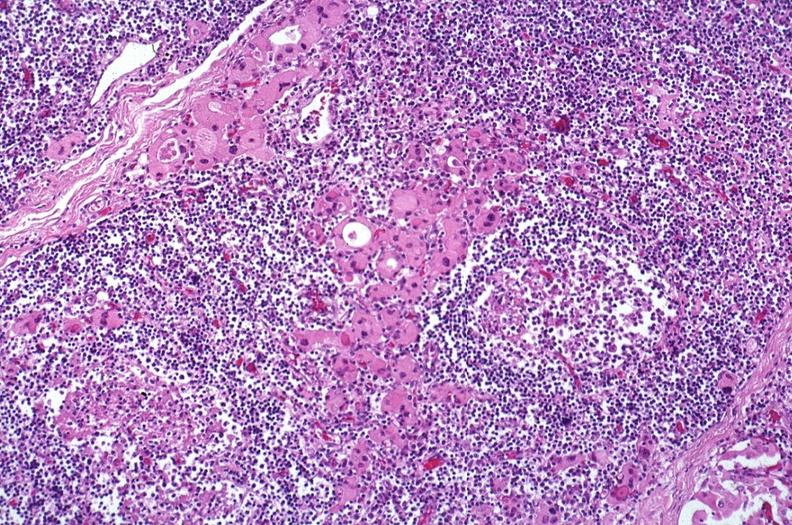does this image show hashimoto 's thyroiditis?
Answer the question using a single word or phrase. Yes 